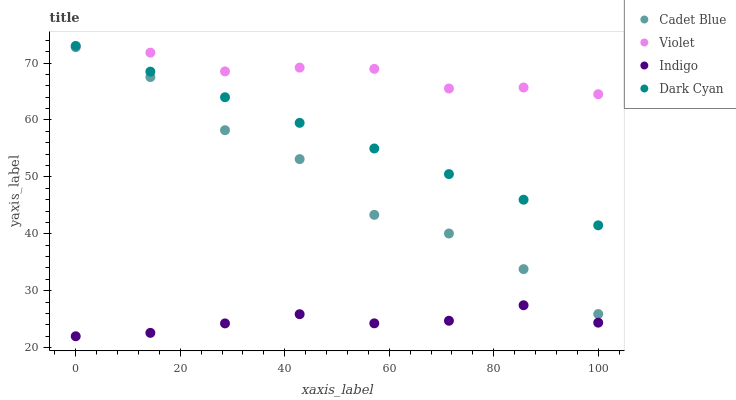Does Indigo have the minimum area under the curve?
Answer yes or no. Yes. Does Violet have the maximum area under the curve?
Answer yes or no. Yes. Does Cadet Blue have the minimum area under the curve?
Answer yes or no. No. Does Cadet Blue have the maximum area under the curve?
Answer yes or no. No. Is Dark Cyan the smoothest?
Answer yes or no. Yes. Is Cadet Blue the roughest?
Answer yes or no. Yes. Is Indigo the smoothest?
Answer yes or no. No. Is Indigo the roughest?
Answer yes or no. No. Does Indigo have the lowest value?
Answer yes or no. Yes. Does Cadet Blue have the lowest value?
Answer yes or no. No. Does Violet have the highest value?
Answer yes or no. Yes. Does Cadet Blue have the highest value?
Answer yes or no. No. Is Cadet Blue less than Violet?
Answer yes or no. Yes. Is Dark Cyan greater than Cadet Blue?
Answer yes or no. Yes. Does Violet intersect Dark Cyan?
Answer yes or no. Yes. Is Violet less than Dark Cyan?
Answer yes or no. No. Is Violet greater than Dark Cyan?
Answer yes or no. No. Does Cadet Blue intersect Violet?
Answer yes or no. No. 